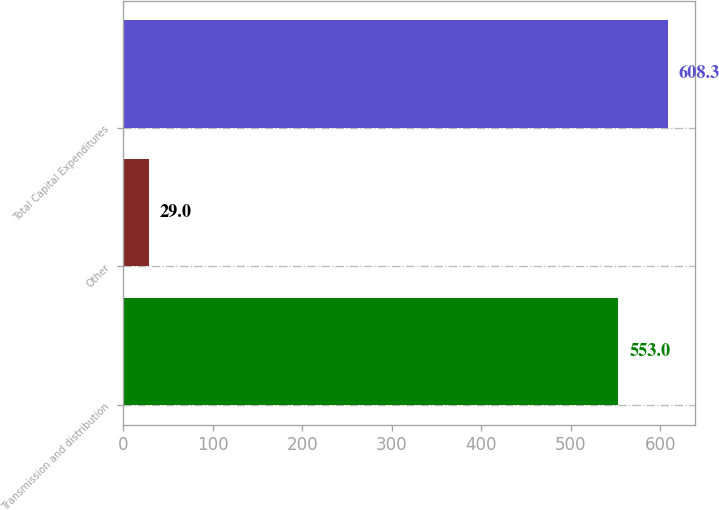Convert chart to OTSL. <chart><loc_0><loc_0><loc_500><loc_500><bar_chart><fcel>Transmission and distribution<fcel>Other<fcel>Total Capital Expenditures<nl><fcel>553<fcel>29<fcel>608.3<nl></chart> 